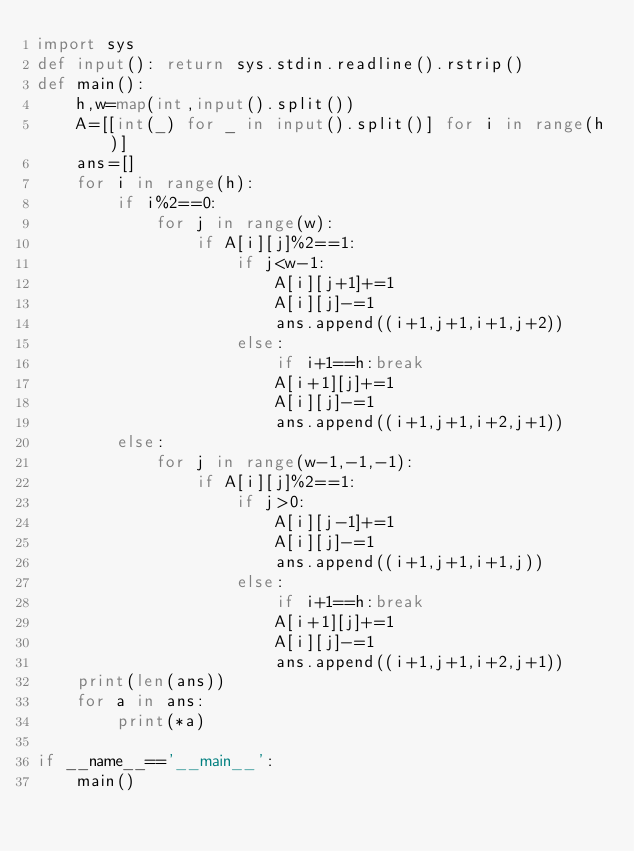Convert code to text. <code><loc_0><loc_0><loc_500><loc_500><_Python_>import sys
def input(): return sys.stdin.readline().rstrip()
def main():
    h,w=map(int,input().split())
    A=[[int(_) for _ in input().split()] for i in range(h)]
    ans=[]
    for i in range(h):
        if i%2==0:
            for j in range(w):
                if A[i][j]%2==1:
                    if j<w-1:
                        A[i][j+1]+=1
                        A[i][j]-=1
                        ans.append((i+1,j+1,i+1,j+2))
                    else:
                        if i+1==h:break
                        A[i+1][j]+=1
                        A[i][j]-=1
                        ans.append((i+1,j+1,i+2,j+1))
        else:
            for j in range(w-1,-1,-1):
                if A[i][j]%2==1:
                    if j>0:
                        A[i][j-1]+=1
                        A[i][j]-=1
                        ans.append((i+1,j+1,i+1,j))
                    else:
                        if i+1==h:break
                        A[i+1][j]+=1
                        A[i][j]-=1
                        ans.append((i+1,j+1,i+2,j+1))
    print(len(ans))
    for a in ans:
        print(*a)

if __name__=='__main__':
    main()</code> 